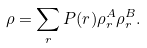<formula> <loc_0><loc_0><loc_500><loc_500>\rho = \sum _ { r } P ( r ) \rho _ { r } ^ { A } \rho _ { r } ^ { B } .</formula> 